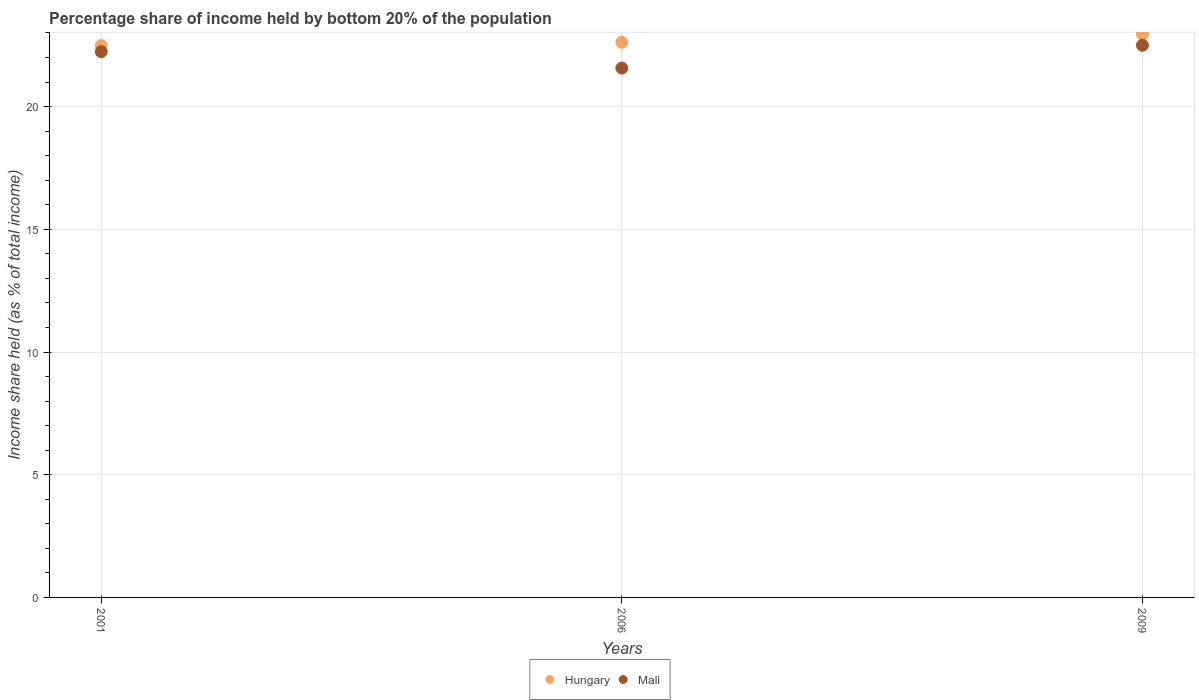Is the number of dotlines equal to the number of legend labels?
Ensure brevity in your answer.  Yes. What is the share of income held by bottom 20% of the population in Hungary in 2009?
Ensure brevity in your answer.  22.96. Across all years, what is the maximum share of income held by bottom 20% of the population in Mali?
Provide a short and direct response. 22.5. Across all years, what is the minimum share of income held by bottom 20% of the population in Hungary?
Keep it short and to the point. 22.49. What is the total share of income held by bottom 20% of the population in Hungary in the graph?
Provide a short and direct response. 68.07. What is the difference between the share of income held by bottom 20% of the population in Hungary in 2006 and that in 2009?
Your response must be concise. -0.34. What is the difference between the share of income held by bottom 20% of the population in Hungary in 2006 and the share of income held by bottom 20% of the population in Mali in 2009?
Provide a succinct answer. 0.12. What is the average share of income held by bottom 20% of the population in Hungary per year?
Provide a succinct answer. 22.69. In the year 2006, what is the difference between the share of income held by bottom 20% of the population in Hungary and share of income held by bottom 20% of the population in Mali?
Your answer should be compact. 1.05. In how many years, is the share of income held by bottom 20% of the population in Mali greater than 21 %?
Ensure brevity in your answer.  3. What is the ratio of the share of income held by bottom 20% of the population in Hungary in 2006 to that in 2009?
Ensure brevity in your answer.  0.99. Is the share of income held by bottom 20% of the population in Mali in 2006 less than that in 2009?
Offer a very short reply. Yes. What is the difference between the highest and the second highest share of income held by bottom 20% of the population in Mali?
Provide a succinct answer. 0.26. What is the difference between the highest and the lowest share of income held by bottom 20% of the population in Mali?
Offer a terse response. 0.93. Does the share of income held by bottom 20% of the population in Hungary monotonically increase over the years?
Your answer should be very brief. Yes. Is the share of income held by bottom 20% of the population in Mali strictly less than the share of income held by bottom 20% of the population in Hungary over the years?
Ensure brevity in your answer.  Yes. What is the difference between two consecutive major ticks on the Y-axis?
Your response must be concise. 5. Does the graph contain any zero values?
Give a very brief answer. No. How many legend labels are there?
Keep it short and to the point. 2. How are the legend labels stacked?
Your answer should be compact. Horizontal. What is the title of the graph?
Offer a terse response. Percentage share of income held by bottom 20% of the population. What is the label or title of the Y-axis?
Offer a very short reply. Income share held (as % of total income). What is the Income share held (as % of total income) in Hungary in 2001?
Provide a succinct answer. 22.49. What is the Income share held (as % of total income) of Mali in 2001?
Offer a very short reply. 22.24. What is the Income share held (as % of total income) of Hungary in 2006?
Make the answer very short. 22.62. What is the Income share held (as % of total income) in Mali in 2006?
Give a very brief answer. 21.57. What is the Income share held (as % of total income) in Hungary in 2009?
Provide a succinct answer. 22.96. Across all years, what is the maximum Income share held (as % of total income) in Hungary?
Offer a terse response. 22.96. Across all years, what is the minimum Income share held (as % of total income) of Hungary?
Your response must be concise. 22.49. Across all years, what is the minimum Income share held (as % of total income) of Mali?
Ensure brevity in your answer.  21.57. What is the total Income share held (as % of total income) in Hungary in the graph?
Make the answer very short. 68.07. What is the total Income share held (as % of total income) in Mali in the graph?
Make the answer very short. 66.31. What is the difference between the Income share held (as % of total income) in Hungary in 2001 and that in 2006?
Provide a short and direct response. -0.13. What is the difference between the Income share held (as % of total income) of Mali in 2001 and that in 2006?
Your answer should be very brief. 0.67. What is the difference between the Income share held (as % of total income) of Hungary in 2001 and that in 2009?
Offer a very short reply. -0.47. What is the difference between the Income share held (as % of total income) of Mali in 2001 and that in 2009?
Make the answer very short. -0.26. What is the difference between the Income share held (as % of total income) in Hungary in 2006 and that in 2009?
Offer a very short reply. -0.34. What is the difference between the Income share held (as % of total income) of Mali in 2006 and that in 2009?
Your response must be concise. -0.93. What is the difference between the Income share held (as % of total income) of Hungary in 2001 and the Income share held (as % of total income) of Mali in 2006?
Keep it short and to the point. 0.92. What is the difference between the Income share held (as % of total income) in Hungary in 2001 and the Income share held (as % of total income) in Mali in 2009?
Ensure brevity in your answer.  -0.01. What is the difference between the Income share held (as % of total income) in Hungary in 2006 and the Income share held (as % of total income) in Mali in 2009?
Give a very brief answer. 0.12. What is the average Income share held (as % of total income) in Hungary per year?
Offer a terse response. 22.69. What is the average Income share held (as % of total income) of Mali per year?
Your answer should be very brief. 22.1. In the year 2006, what is the difference between the Income share held (as % of total income) of Hungary and Income share held (as % of total income) of Mali?
Keep it short and to the point. 1.05. In the year 2009, what is the difference between the Income share held (as % of total income) of Hungary and Income share held (as % of total income) of Mali?
Offer a terse response. 0.46. What is the ratio of the Income share held (as % of total income) of Mali in 2001 to that in 2006?
Ensure brevity in your answer.  1.03. What is the ratio of the Income share held (as % of total income) in Hungary in 2001 to that in 2009?
Provide a short and direct response. 0.98. What is the ratio of the Income share held (as % of total income) of Mali in 2001 to that in 2009?
Provide a succinct answer. 0.99. What is the ratio of the Income share held (as % of total income) of Hungary in 2006 to that in 2009?
Provide a short and direct response. 0.99. What is the ratio of the Income share held (as % of total income) of Mali in 2006 to that in 2009?
Give a very brief answer. 0.96. What is the difference between the highest and the second highest Income share held (as % of total income) in Hungary?
Keep it short and to the point. 0.34. What is the difference between the highest and the second highest Income share held (as % of total income) in Mali?
Offer a terse response. 0.26. What is the difference between the highest and the lowest Income share held (as % of total income) in Hungary?
Provide a succinct answer. 0.47. What is the difference between the highest and the lowest Income share held (as % of total income) of Mali?
Your response must be concise. 0.93. 